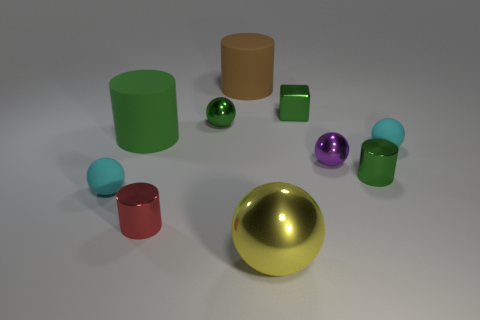Subtract all small green shiny balls. How many balls are left? 4 Subtract all cyan cubes. How many green cylinders are left? 2 Subtract all red cylinders. How many cylinders are left? 3 Subtract 3 spheres. How many spheres are left? 2 Subtract all brown cylinders. Subtract all gray balls. How many cylinders are left? 3 Subtract all cylinders. How many objects are left? 6 Subtract all small purple metallic cubes. Subtract all small red metallic cylinders. How many objects are left? 9 Add 2 small spheres. How many small spheres are left? 6 Add 2 yellow spheres. How many yellow spheres exist? 3 Subtract 0 blue spheres. How many objects are left? 10 